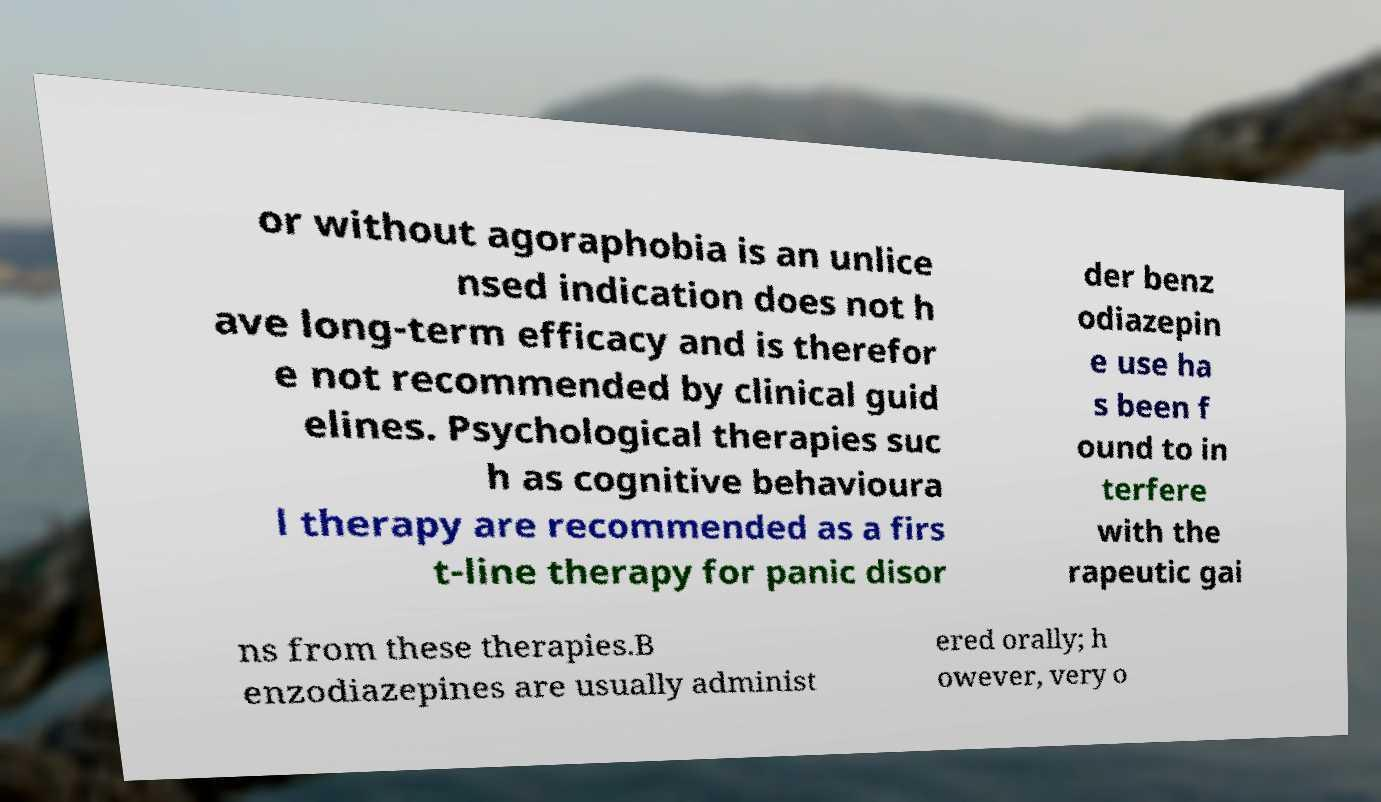For documentation purposes, I need the text within this image transcribed. Could you provide that? or without agoraphobia is an unlice nsed indication does not h ave long-term efficacy and is therefor e not recommended by clinical guid elines. Psychological therapies suc h as cognitive behavioura l therapy are recommended as a firs t-line therapy for panic disor der benz odiazepin e use ha s been f ound to in terfere with the rapeutic gai ns from these therapies.B enzodiazepines are usually administ ered orally; h owever, very o 